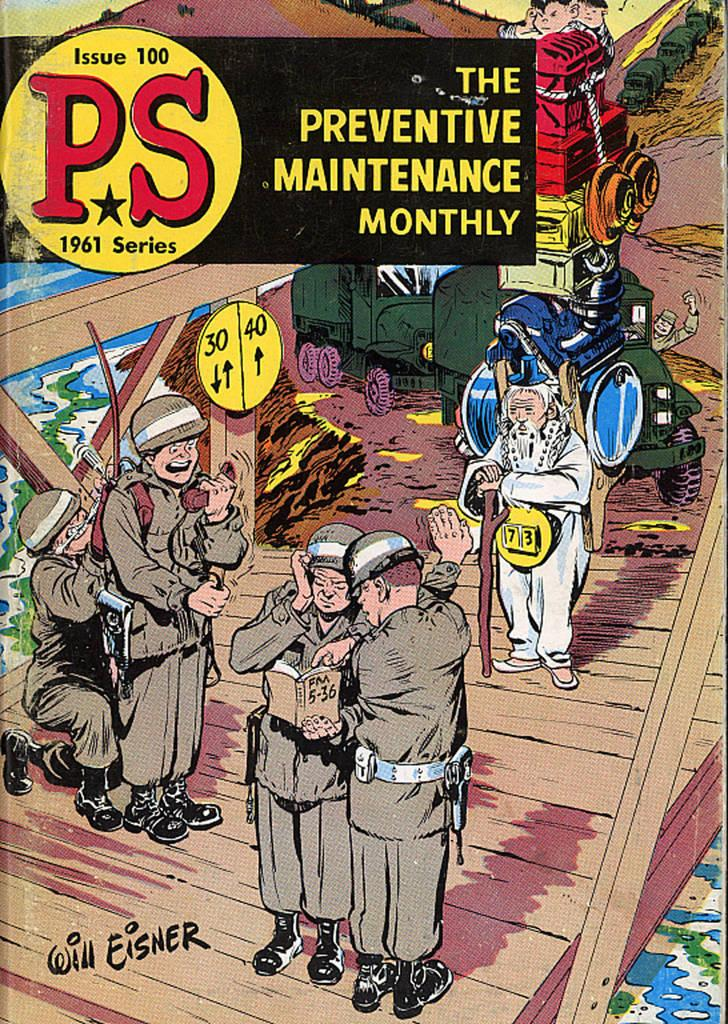<image>
Create a compact narrative representing the image presented. Cover of issue 100 of PS from 1961 